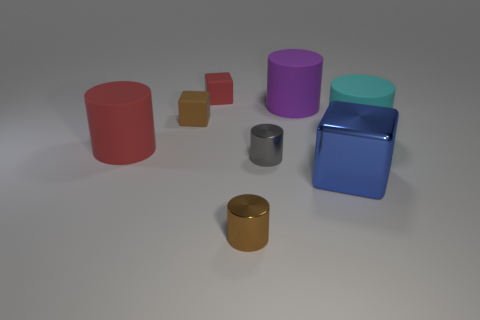What is the shape of the purple object that is made of the same material as the large cyan thing?
Keep it short and to the point. Cylinder. Does the purple matte thing have the same shape as the gray metallic object?
Offer a very short reply. Yes. What is the color of the metal block?
Offer a terse response. Blue. What number of things are either purple cylinders or red balls?
Provide a short and direct response. 1. Is there anything else that is made of the same material as the red cube?
Ensure brevity in your answer.  Yes. Is the number of large red matte cylinders left of the large cyan object less than the number of big green shiny spheres?
Make the answer very short. No. Are there more large blue metallic things behind the small brown rubber block than metal objects that are behind the big purple cylinder?
Ensure brevity in your answer.  No. Is there anything else that is the same color as the large block?
Ensure brevity in your answer.  No. What material is the tiny brown object that is behind the large blue block?
Your answer should be very brief. Rubber. Is the size of the gray object the same as the red cylinder?
Ensure brevity in your answer.  No. 